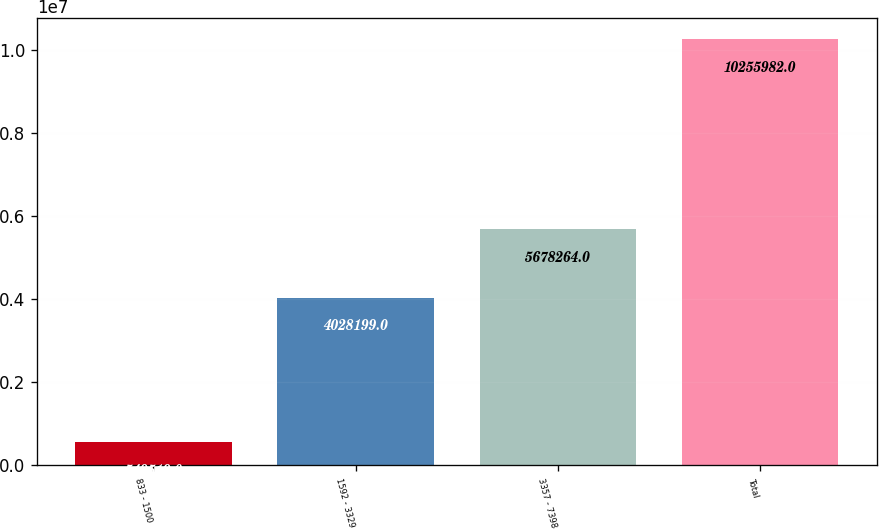Convert chart to OTSL. <chart><loc_0><loc_0><loc_500><loc_500><bar_chart><fcel>833 - 1500<fcel>1592 - 3329<fcel>3357 - 7398<fcel>Total<nl><fcel>549519<fcel>4.0282e+06<fcel>5.67826e+06<fcel>1.0256e+07<nl></chart> 